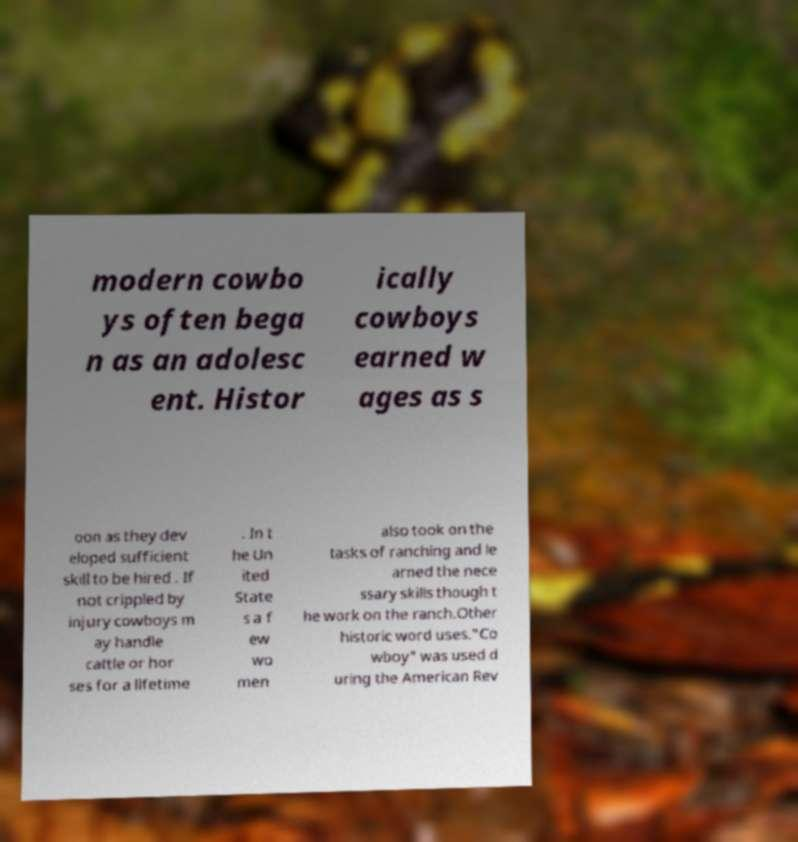Could you extract and type out the text from this image? modern cowbo ys often bega n as an adolesc ent. Histor ically cowboys earned w ages as s oon as they dev eloped sufficient skill to be hired . If not crippled by injury cowboys m ay handle cattle or hor ses for a lifetime . In t he Un ited State s a f ew wo men also took on the tasks of ranching and le arned the nece ssary skills though t he work on the ranch.Other historic word uses."Co wboy" was used d uring the American Rev 